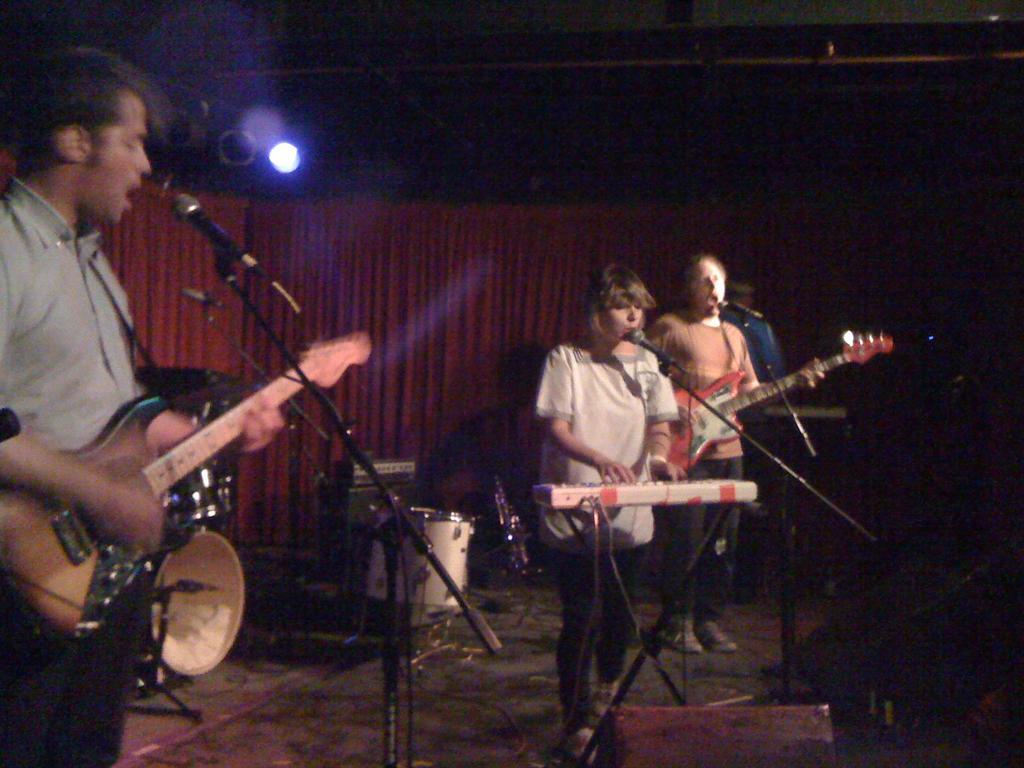Please provide a concise description of this image. This picture describes about group of people they are playing some musical instruments in front of microphone, and around them we can find some musical instruments, in the background we can find curtains and light. 